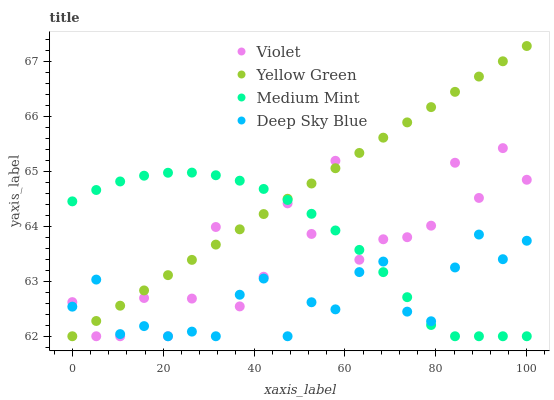Does Deep Sky Blue have the minimum area under the curve?
Answer yes or no. Yes. Does Yellow Green have the maximum area under the curve?
Answer yes or no. Yes. Does Yellow Green have the minimum area under the curve?
Answer yes or no. No. Does Deep Sky Blue have the maximum area under the curve?
Answer yes or no. No. Is Yellow Green the smoothest?
Answer yes or no. Yes. Is Violet the roughest?
Answer yes or no. Yes. Is Deep Sky Blue the smoothest?
Answer yes or no. No. Is Deep Sky Blue the roughest?
Answer yes or no. No. Does Medium Mint have the lowest value?
Answer yes or no. Yes. Does Yellow Green have the highest value?
Answer yes or no. Yes. Does Deep Sky Blue have the highest value?
Answer yes or no. No. Does Yellow Green intersect Medium Mint?
Answer yes or no. Yes. Is Yellow Green less than Medium Mint?
Answer yes or no. No. Is Yellow Green greater than Medium Mint?
Answer yes or no. No. 